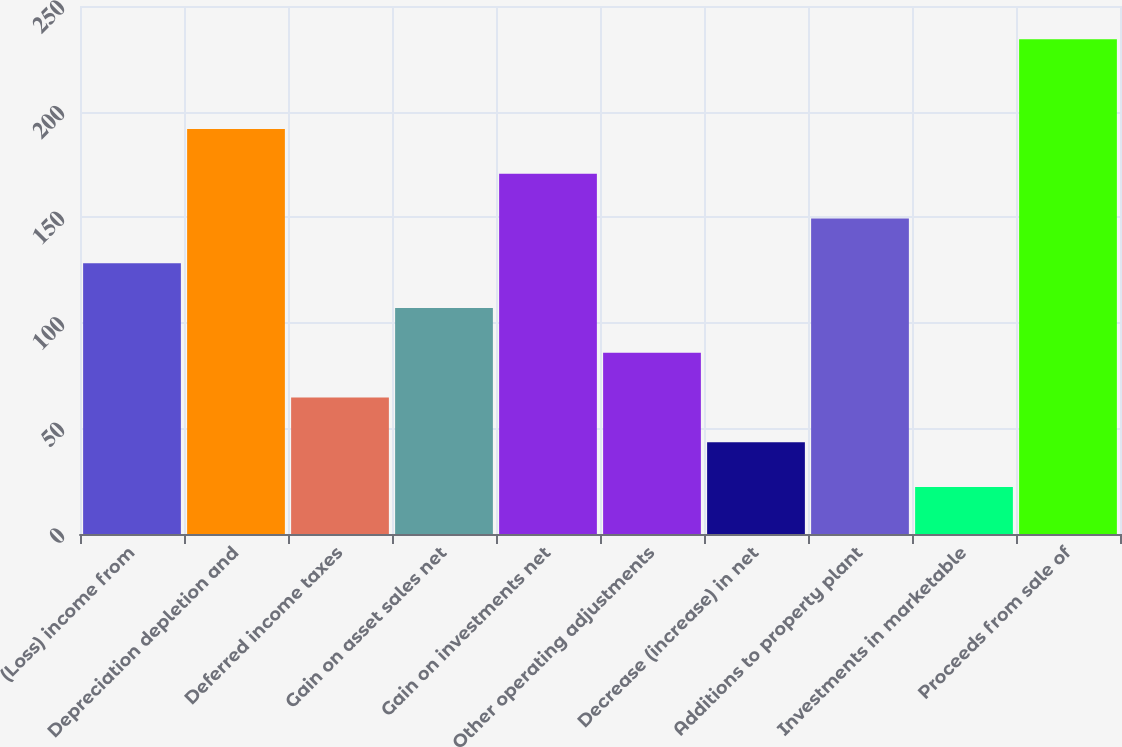<chart> <loc_0><loc_0><loc_500><loc_500><bar_chart><fcel>(Loss) income from<fcel>Depreciation depletion and<fcel>Deferred income taxes<fcel>Gain on asset sales net<fcel>Gain on investments net<fcel>Other operating adjustments<fcel>Decrease (increase) in net<fcel>Additions to property plant<fcel>Investments in marketable<fcel>Proceeds from sale of<nl><fcel>128.2<fcel>191.8<fcel>64.6<fcel>107<fcel>170.6<fcel>85.8<fcel>43.4<fcel>149.4<fcel>22.2<fcel>234.2<nl></chart> 